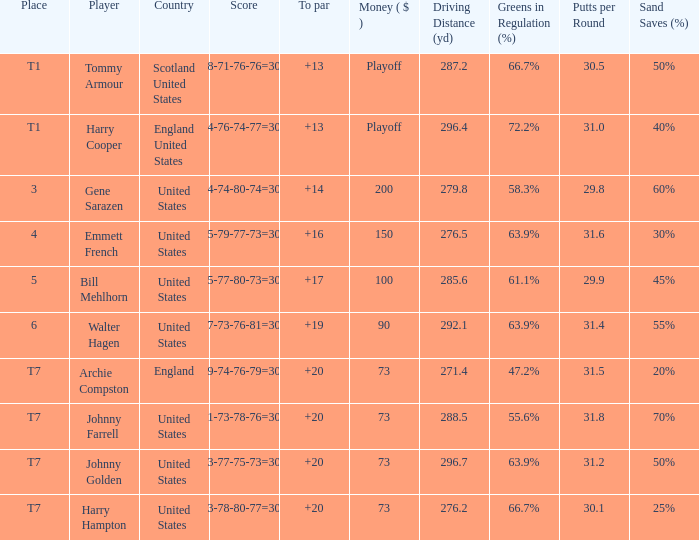Which country has a to par less than 19 and a score of 75-79-77-73=304? United States. 